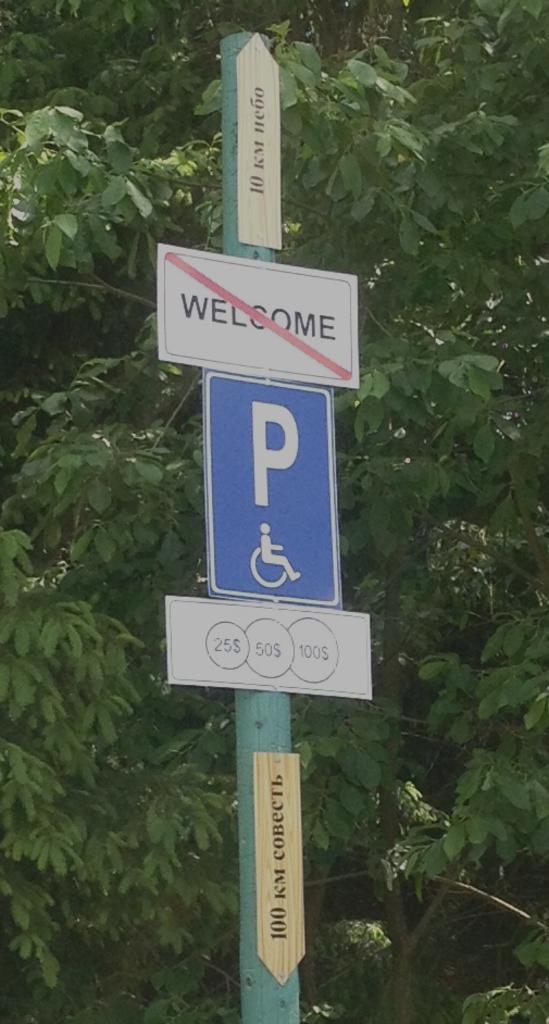How would you summarize this image in a sentence or two? In this picture I can observe a pole to which three boards are fixed. In the background I can observe trees. 